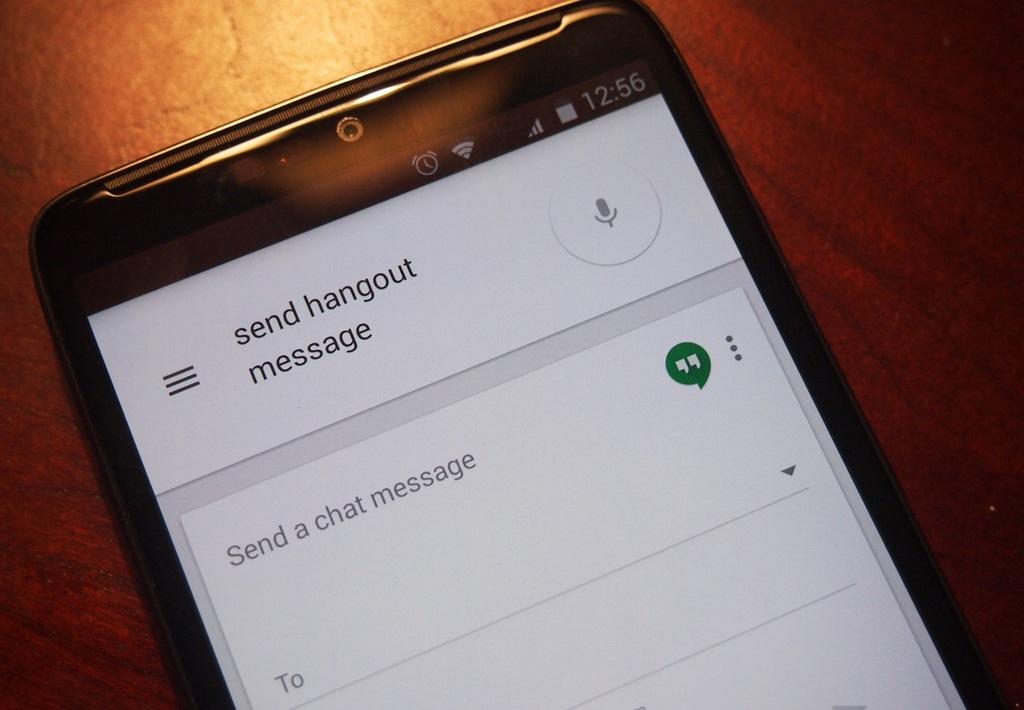Send a chat what?
Offer a terse response. Message. What type of message can you send?
Provide a succinct answer. Hangout. 